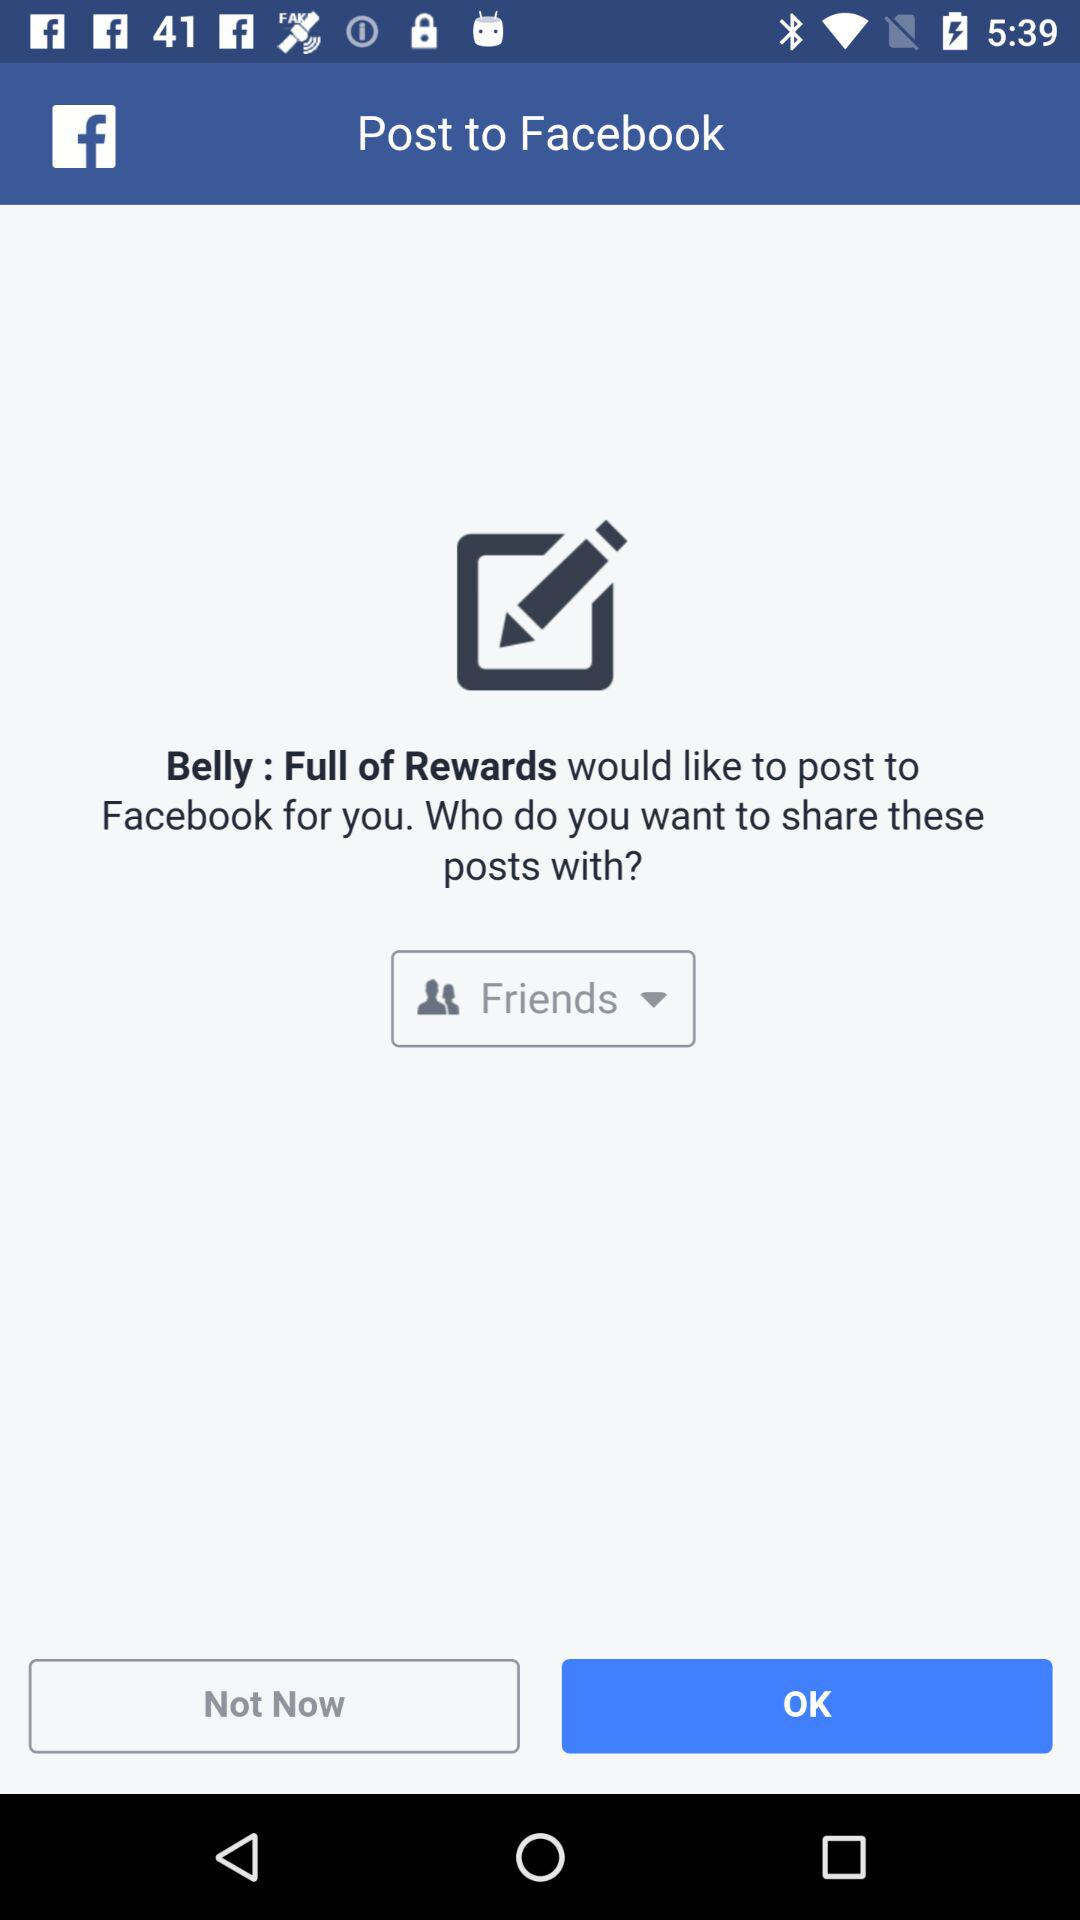What application will post to Facebook for me? The application is "Belly : Full of Rewards". 